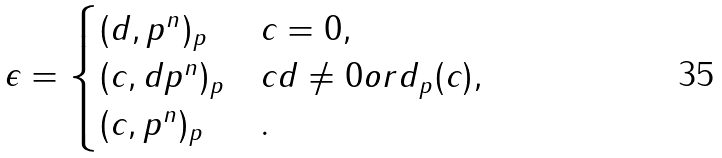<formula> <loc_0><loc_0><loc_500><loc_500>\epsilon = \begin{cases} ( d , p ^ { n } ) _ { p } & c = 0 , \\ ( c , d p ^ { n } ) _ { p } & c d \neq 0 o r d _ { p } ( c ) , \\ ( c , p ^ { n } ) _ { p } & . \end{cases}</formula> 